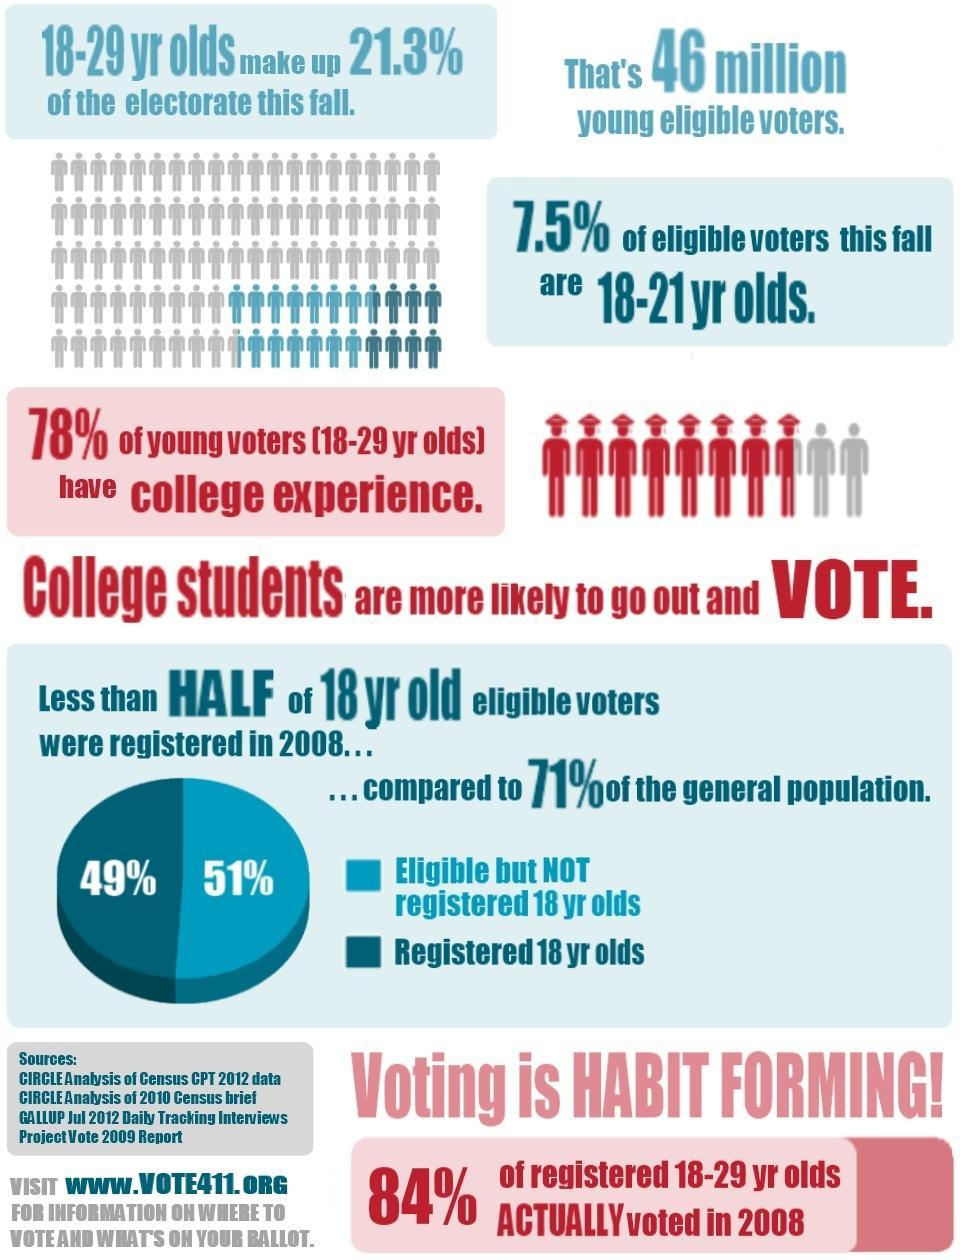What percent of voters are registered 18 year olds according to the pie chart?
Answer the question with a short phrase. 49% How many sources are given? 4 